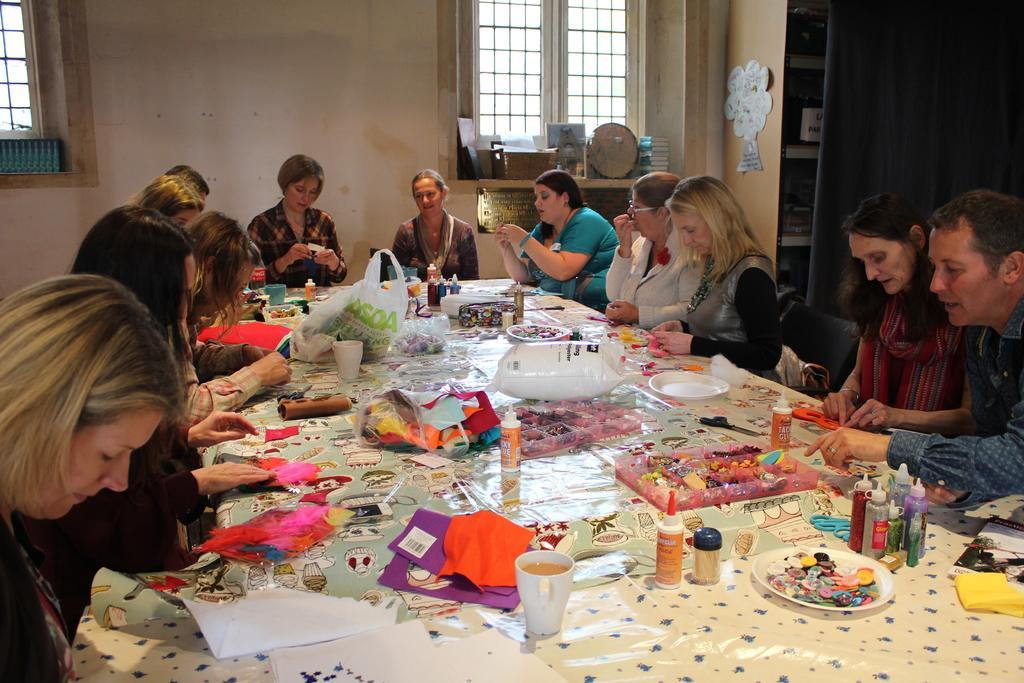How would you summarize this image in a sentence or two? There are many persons sitting around a table. On the table there are plates, glasses, bottles, balloons, covers, buttons, toothpick, paper and many other items. in the background there is a wall, windows. Some books are kept near the window. And there is a nameplate on the wall. 